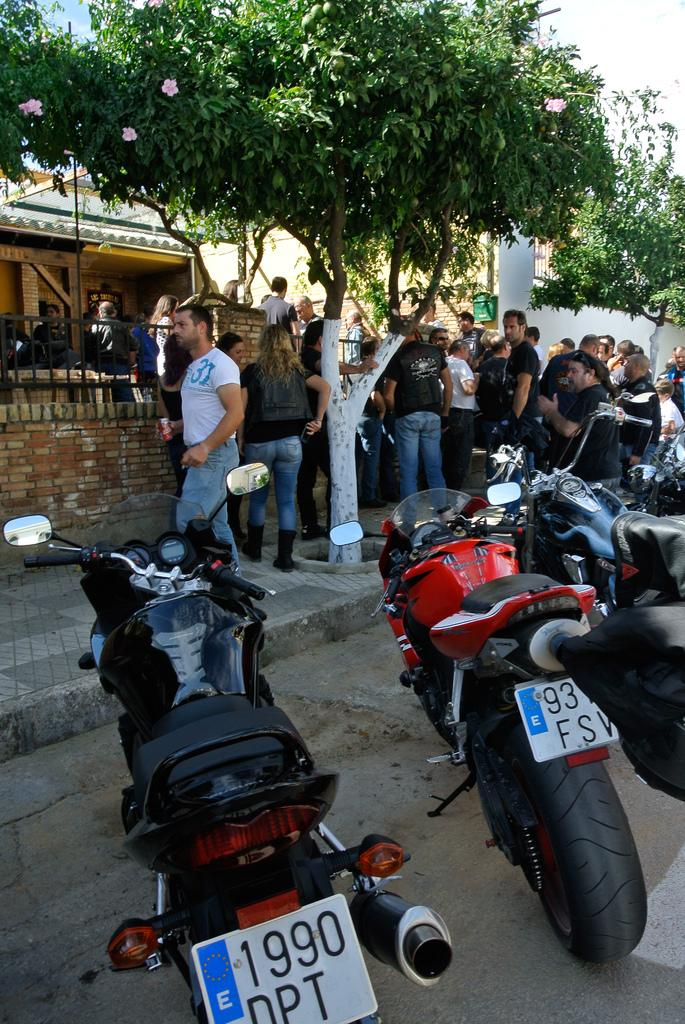What type of vehicles are present in the image? There are sports bikes in the image. Where are the bikes located? The bikes are parked in the front. What are the people in the image doing? There are people standing and discussing in the image. What can be seen in the background of the image? There is a brown house and trees in the background of the image. What type of attraction can be seen in the image? There is no attraction present in the image; it features sports bikes, people, and a brown house in the background. What type of joke is being told by the people in the image? There is no indication of a joke being told in the image; the people are simply standing and discussing. 